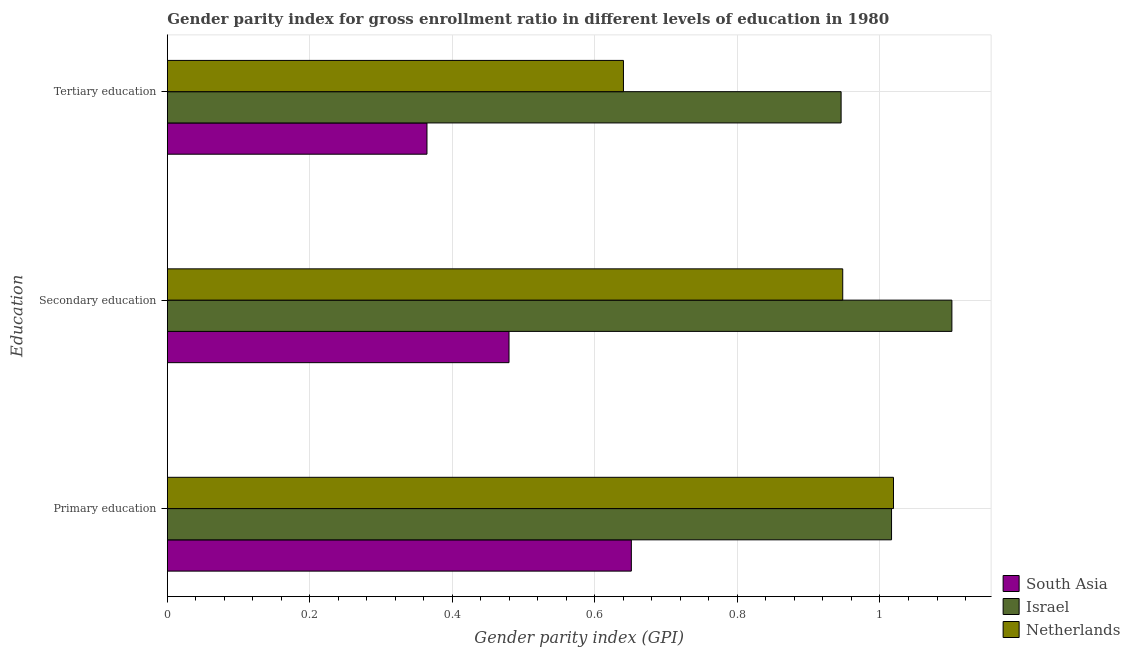How many groups of bars are there?
Offer a terse response. 3. Are the number of bars per tick equal to the number of legend labels?
Give a very brief answer. Yes. What is the gender parity index in secondary education in South Asia?
Offer a terse response. 0.48. Across all countries, what is the maximum gender parity index in primary education?
Make the answer very short. 1.02. Across all countries, what is the minimum gender parity index in primary education?
Keep it short and to the point. 0.65. In which country was the gender parity index in tertiary education maximum?
Your response must be concise. Israel. In which country was the gender parity index in secondary education minimum?
Offer a terse response. South Asia. What is the total gender parity index in secondary education in the graph?
Provide a succinct answer. 2.53. What is the difference between the gender parity index in primary education in Netherlands and that in South Asia?
Offer a terse response. 0.37. What is the difference between the gender parity index in secondary education in Netherlands and the gender parity index in tertiary education in South Asia?
Offer a very short reply. 0.58. What is the average gender parity index in primary education per country?
Keep it short and to the point. 0.9. What is the difference between the gender parity index in primary education and gender parity index in tertiary education in Netherlands?
Your answer should be very brief. 0.38. What is the ratio of the gender parity index in tertiary education in Netherlands to that in South Asia?
Your answer should be very brief. 1.76. Is the gender parity index in secondary education in South Asia less than that in Netherlands?
Your response must be concise. Yes. What is the difference between the highest and the second highest gender parity index in primary education?
Provide a short and direct response. 0. What is the difference between the highest and the lowest gender parity index in tertiary education?
Offer a very short reply. 0.58. What does the 2nd bar from the bottom in Secondary education represents?
Offer a terse response. Israel. How many bars are there?
Your answer should be very brief. 9. Are all the bars in the graph horizontal?
Your response must be concise. Yes. How many countries are there in the graph?
Ensure brevity in your answer.  3. What is the difference between two consecutive major ticks on the X-axis?
Keep it short and to the point. 0.2. Does the graph contain any zero values?
Make the answer very short. No. What is the title of the graph?
Keep it short and to the point. Gender parity index for gross enrollment ratio in different levels of education in 1980. What is the label or title of the X-axis?
Your answer should be compact. Gender parity index (GPI). What is the label or title of the Y-axis?
Your answer should be compact. Education. What is the Gender parity index (GPI) in South Asia in Primary education?
Provide a succinct answer. 0.65. What is the Gender parity index (GPI) of Israel in Primary education?
Your answer should be compact. 1.02. What is the Gender parity index (GPI) of Netherlands in Primary education?
Make the answer very short. 1.02. What is the Gender parity index (GPI) of South Asia in Secondary education?
Keep it short and to the point. 0.48. What is the Gender parity index (GPI) of Israel in Secondary education?
Provide a succinct answer. 1.1. What is the Gender parity index (GPI) in Netherlands in Secondary education?
Ensure brevity in your answer.  0.95. What is the Gender parity index (GPI) of South Asia in Tertiary education?
Make the answer very short. 0.36. What is the Gender parity index (GPI) in Israel in Tertiary education?
Offer a terse response. 0.95. What is the Gender parity index (GPI) in Netherlands in Tertiary education?
Your response must be concise. 0.64. Across all Education, what is the maximum Gender parity index (GPI) in South Asia?
Your answer should be very brief. 0.65. Across all Education, what is the maximum Gender parity index (GPI) of Israel?
Your answer should be very brief. 1.1. Across all Education, what is the maximum Gender parity index (GPI) of Netherlands?
Keep it short and to the point. 1.02. Across all Education, what is the minimum Gender parity index (GPI) of South Asia?
Make the answer very short. 0.36. Across all Education, what is the minimum Gender parity index (GPI) of Israel?
Your answer should be compact. 0.95. Across all Education, what is the minimum Gender parity index (GPI) of Netherlands?
Your answer should be compact. 0.64. What is the total Gender parity index (GPI) of South Asia in the graph?
Provide a succinct answer. 1.49. What is the total Gender parity index (GPI) in Israel in the graph?
Ensure brevity in your answer.  3.06. What is the total Gender parity index (GPI) of Netherlands in the graph?
Your answer should be very brief. 2.61. What is the difference between the Gender parity index (GPI) in South Asia in Primary education and that in Secondary education?
Make the answer very short. 0.17. What is the difference between the Gender parity index (GPI) of Israel in Primary education and that in Secondary education?
Your answer should be very brief. -0.08. What is the difference between the Gender parity index (GPI) in Netherlands in Primary education and that in Secondary education?
Provide a succinct answer. 0.07. What is the difference between the Gender parity index (GPI) in South Asia in Primary education and that in Tertiary education?
Ensure brevity in your answer.  0.29. What is the difference between the Gender parity index (GPI) of Israel in Primary education and that in Tertiary education?
Give a very brief answer. 0.07. What is the difference between the Gender parity index (GPI) of Netherlands in Primary education and that in Tertiary education?
Your response must be concise. 0.38. What is the difference between the Gender parity index (GPI) of South Asia in Secondary education and that in Tertiary education?
Make the answer very short. 0.12. What is the difference between the Gender parity index (GPI) of Israel in Secondary education and that in Tertiary education?
Ensure brevity in your answer.  0.16. What is the difference between the Gender parity index (GPI) in Netherlands in Secondary education and that in Tertiary education?
Your response must be concise. 0.31. What is the difference between the Gender parity index (GPI) of South Asia in Primary education and the Gender parity index (GPI) of Israel in Secondary education?
Your response must be concise. -0.45. What is the difference between the Gender parity index (GPI) of South Asia in Primary education and the Gender parity index (GPI) of Netherlands in Secondary education?
Your answer should be compact. -0.3. What is the difference between the Gender parity index (GPI) in Israel in Primary education and the Gender parity index (GPI) in Netherlands in Secondary education?
Offer a terse response. 0.07. What is the difference between the Gender parity index (GPI) of South Asia in Primary education and the Gender parity index (GPI) of Israel in Tertiary education?
Give a very brief answer. -0.29. What is the difference between the Gender parity index (GPI) in South Asia in Primary education and the Gender parity index (GPI) in Netherlands in Tertiary education?
Provide a succinct answer. 0.01. What is the difference between the Gender parity index (GPI) of Israel in Primary education and the Gender parity index (GPI) of Netherlands in Tertiary education?
Make the answer very short. 0.38. What is the difference between the Gender parity index (GPI) of South Asia in Secondary education and the Gender parity index (GPI) of Israel in Tertiary education?
Offer a terse response. -0.47. What is the difference between the Gender parity index (GPI) in South Asia in Secondary education and the Gender parity index (GPI) in Netherlands in Tertiary education?
Your answer should be compact. -0.16. What is the difference between the Gender parity index (GPI) in Israel in Secondary education and the Gender parity index (GPI) in Netherlands in Tertiary education?
Keep it short and to the point. 0.46. What is the average Gender parity index (GPI) in South Asia per Education?
Your response must be concise. 0.5. What is the average Gender parity index (GPI) of Israel per Education?
Provide a short and direct response. 1.02. What is the average Gender parity index (GPI) of Netherlands per Education?
Your answer should be compact. 0.87. What is the difference between the Gender parity index (GPI) of South Asia and Gender parity index (GPI) of Israel in Primary education?
Give a very brief answer. -0.37. What is the difference between the Gender parity index (GPI) of South Asia and Gender parity index (GPI) of Netherlands in Primary education?
Ensure brevity in your answer.  -0.37. What is the difference between the Gender parity index (GPI) of Israel and Gender parity index (GPI) of Netherlands in Primary education?
Your answer should be very brief. -0. What is the difference between the Gender parity index (GPI) of South Asia and Gender parity index (GPI) of Israel in Secondary education?
Offer a very short reply. -0.62. What is the difference between the Gender parity index (GPI) of South Asia and Gender parity index (GPI) of Netherlands in Secondary education?
Offer a terse response. -0.47. What is the difference between the Gender parity index (GPI) in Israel and Gender parity index (GPI) in Netherlands in Secondary education?
Give a very brief answer. 0.15. What is the difference between the Gender parity index (GPI) in South Asia and Gender parity index (GPI) in Israel in Tertiary education?
Your response must be concise. -0.58. What is the difference between the Gender parity index (GPI) of South Asia and Gender parity index (GPI) of Netherlands in Tertiary education?
Keep it short and to the point. -0.28. What is the difference between the Gender parity index (GPI) in Israel and Gender parity index (GPI) in Netherlands in Tertiary education?
Offer a very short reply. 0.31. What is the ratio of the Gender parity index (GPI) of South Asia in Primary education to that in Secondary education?
Give a very brief answer. 1.36. What is the ratio of the Gender parity index (GPI) in Netherlands in Primary education to that in Secondary education?
Your response must be concise. 1.08. What is the ratio of the Gender parity index (GPI) in South Asia in Primary education to that in Tertiary education?
Make the answer very short. 1.79. What is the ratio of the Gender parity index (GPI) in Israel in Primary education to that in Tertiary education?
Your answer should be compact. 1.07. What is the ratio of the Gender parity index (GPI) of Netherlands in Primary education to that in Tertiary education?
Keep it short and to the point. 1.59. What is the ratio of the Gender parity index (GPI) of South Asia in Secondary education to that in Tertiary education?
Offer a very short reply. 1.32. What is the ratio of the Gender parity index (GPI) in Israel in Secondary education to that in Tertiary education?
Offer a terse response. 1.16. What is the ratio of the Gender parity index (GPI) of Netherlands in Secondary education to that in Tertiary education?
Ensure brevity in your answer.  1.48. What is the difference between the highest and the second highest Gender parity index (GPI) of South Asia?
Your answer should be very brief. 0.17. What is the difference between the highest and the second highest Gender parity index (GPI) of Israel?
Offer a very short reply. 0.08. What is the difference between the highest and the second highest Gender parity index (GPI) in Netherlands?
Offer a very short reply. 0.07. What is the difference between the highest and the lowest Gender parity index (GPI) in South Asia?
Make the answer very short. 0.29. What is the difference between the highest and the lowest Gender parity index (GPI) of Israel?
Offer a very short reply. 0.16. What is the difference between the highest and the lowest Gender parity index (GPI) in Netherlands?
Your response must be concise. 0.38. 